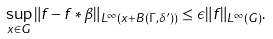<formula> <loc_0><loc_0><loc_500><loc_500>\sup _ { x \in G } { \| f - f \ast \beta \| _ { L ^ { \infty } ( x + B ( \Gamma , \delta ^ { \prime } ) ) } } \leq \epsilon \| f \| _ { L ^ { \infty } ( G ) } .</formula> 